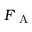Convert formula to latex. <formula><loc_0><loc_0><loc_500><loc_500>F _ { A }</formula> 